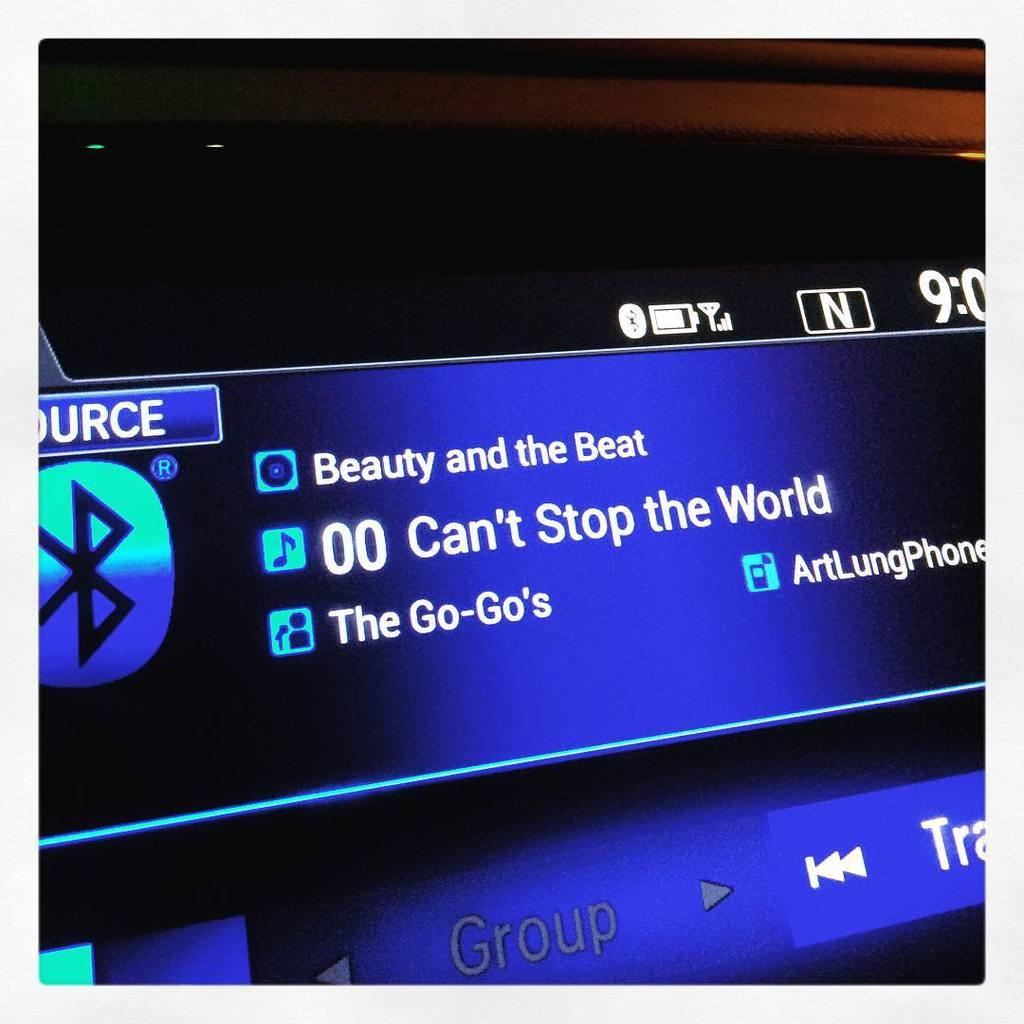<image>
Present a compact description of the photo's key features. A computer is playing the song Beauty and the Beat. 